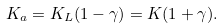<formula> <loc_0><loc_0><loc_500><loc_500>K _ { a } = K _ { L } ( 1 - \gamma ) = K ( 1 + \gamma ) .</formula> 